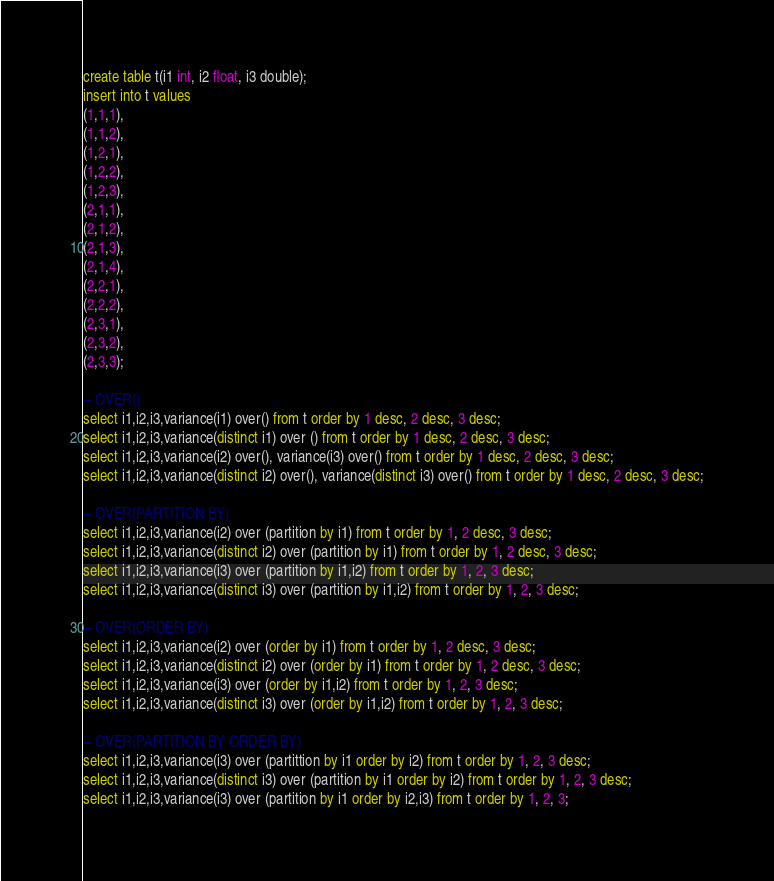<code> <loc_0><loc_0><loc_500><loc_500><_SQL_>
create table t(i1 int, i2 float, i3 double);
insert into t values
(1,1,1),
(1,1,2),
(1,2,1),
(1,2,2),
(1,2,3),
(2,1,1),
(2,1,2),
(2,1,3),
(2,1,4),
(2,2,1),
(2,2,2),
(2,3,1),
(2,3,2),
(2,3,3);

-- OVER()
select i1,i2,i3,variance(i1) over() from t order by 1 desc, 2 desc, 3 desc;
select i1,i2,i3,variance(distinct i1) over () from t order by 1 desc, 2 desc, 3 desc;
select i1,i2,i3,variance(i2) over(), variance(i3) over() from t order by 1 desc, 2 desc, 3 desc;
select i1,i2,i3,variance(distinct i2) over(), variance(distinct i3) over() from t order by 1 desc, 2 desc, 3 desc;

-- OVER(PARTITION BY)
select i1,i2,i3,variance(i2) over (partition by i1) from t order by 1, 2 desc, 3 desc;
select i1,i2,i3,variance(distinct i2) over (partition by i1) from t order by 1, 2 desc, 3 desc;
select i1,i2,i3,variance(i3) over (partition by i1,i2) from t order by 1, 2, 3 desc;
select i1,i2,i3,variance(distinct i3) over (partition by i1,i2) from t order by 1, 2, 3 desc;

-- OVER(ORDER BY)
select i1,i2,i3,variance(i2) over (order by i1) from t order by 1, 2 desc, 3 desc;
select i1,i2,i3,variance(distinct i2) over (order by i1) from t order by 1, 2 desc, 3 desc;
select i1,i2,i3,variance(i3) over (order by i1,i2) from t order by 1, 2, 3 desc;
select i1,i2,i3,variance(distinct i3) over (order by i1,i2) from t order by 1, 2, 3 desc;

-- OVER(PARTITION BY ORDER BY)
select i1,i2,i3,variance(i3) over (partittion by i1 order by i2) from t order by 1, 2, 3 desc;
select i1,i2,i3,variance(distinct i3) over (partition by i1 order by i2) from t order by 1, 2, 3 desc;
select i1,i2,i3,variance(i3) over (partition by i1 order by i2,i3) from t order by 1, 2, 3;</code> 